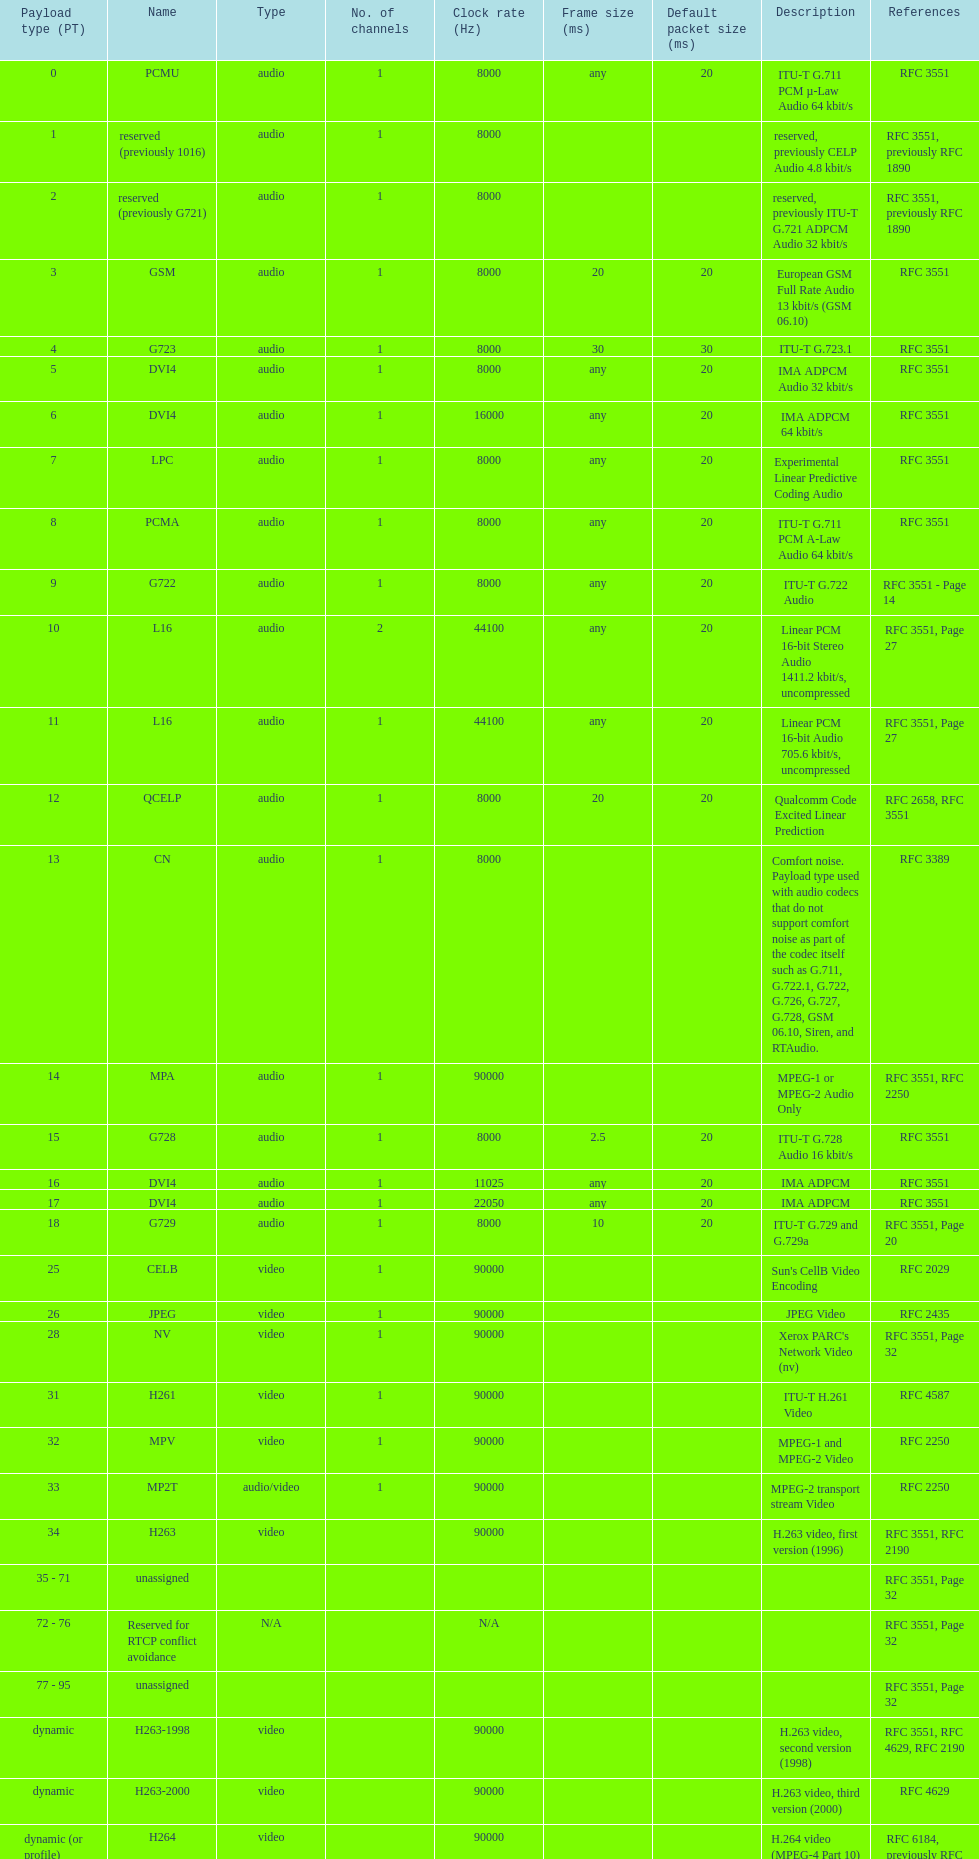The rtp/avp audio and video payload types include an audio type called qcelp and its frame size is how many ms? 20. 